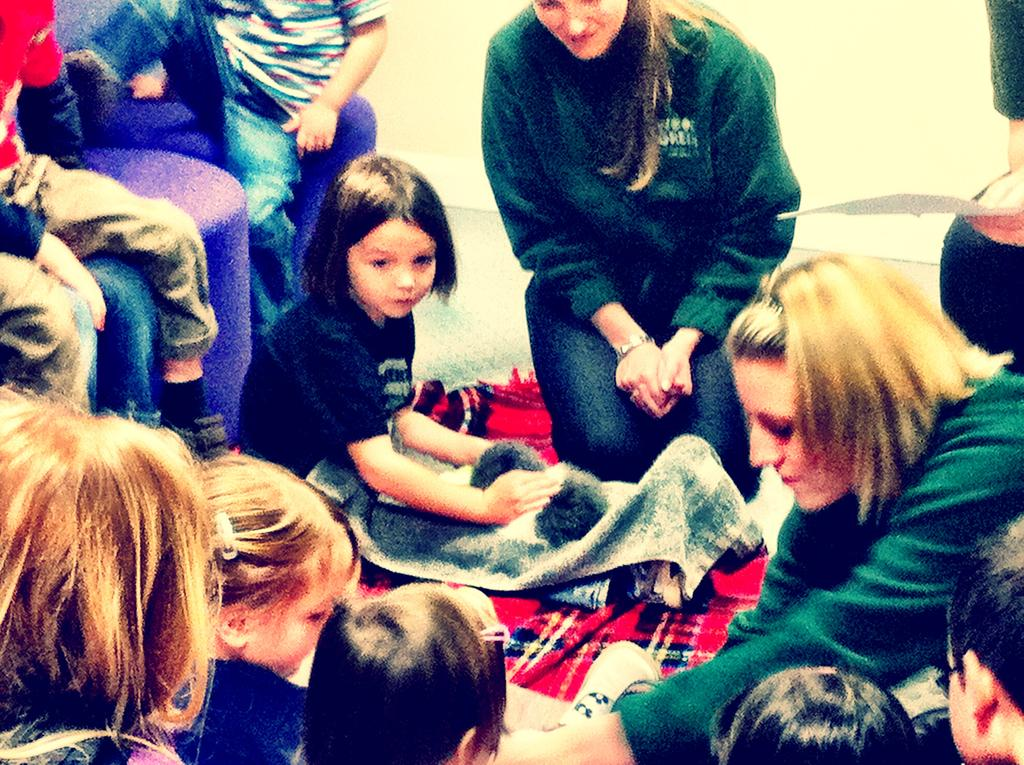What are the people in the image doing? The people in the image are sitting. What else can be seen in the image besides the people? Clothes are visible in the image. How many bees can be seen buzzing around the hydrant in the image? There are no bees or hydrants present in the image. 